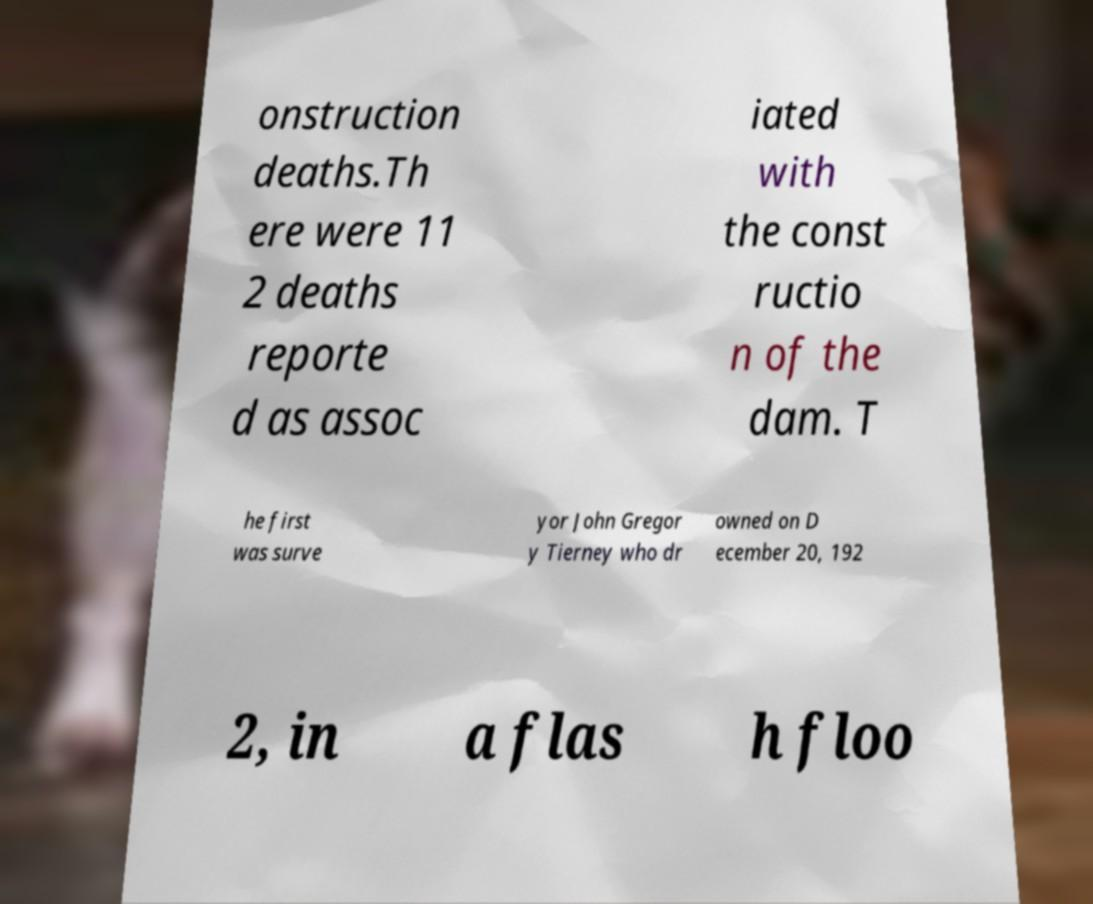Please identify and transcribe the text found in this image. onstruction deaths.Th ere were 11 2 deaths reporte d as assoc iated with the const ructio n of the dam. T he first was surve yor John Gregor y Tierney who dr owned on D ecember 20, 192 2, in a flas h floo 